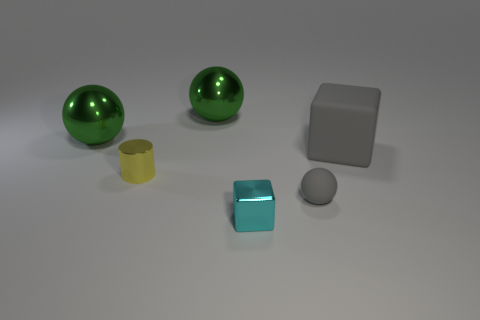The large thing that is the same material as the gray sphere is what shape?
Your response must be concise. Cube. Are the cyan cube and the big gray object made of the same material?
Offer a terse response. No. Is the number of green shiny objects that are in front of the cyan shiny object less than the number of yellow cylinders that are behind the gray matte block?
Your answer should be compact. No. There is a rubber block that is the same color as the rubber sphere; what size is it?
Your response must be concise. Large. What number of yellow objects are to the right of the block left of the matte thing in front of the large rubber thing?
Offer a terse response. 0. Is the color of the tiny ball the same as the cylinder?
Your response must be concise. No. Is there a tiny metal cylinder that has the same color as the small matte object?
Provide a succinct answer. No. The metal cylinder that is the same size as the metallic block is what color?
Provide a short and direct response. Yellow. Are there any other small objects that have the same shape as the small yellow metallic object?
Make the answer very short. No. There is a tiny object that is the same color as the large rubber thing; what is its shape?
Offer a very short reply. Sphere. 